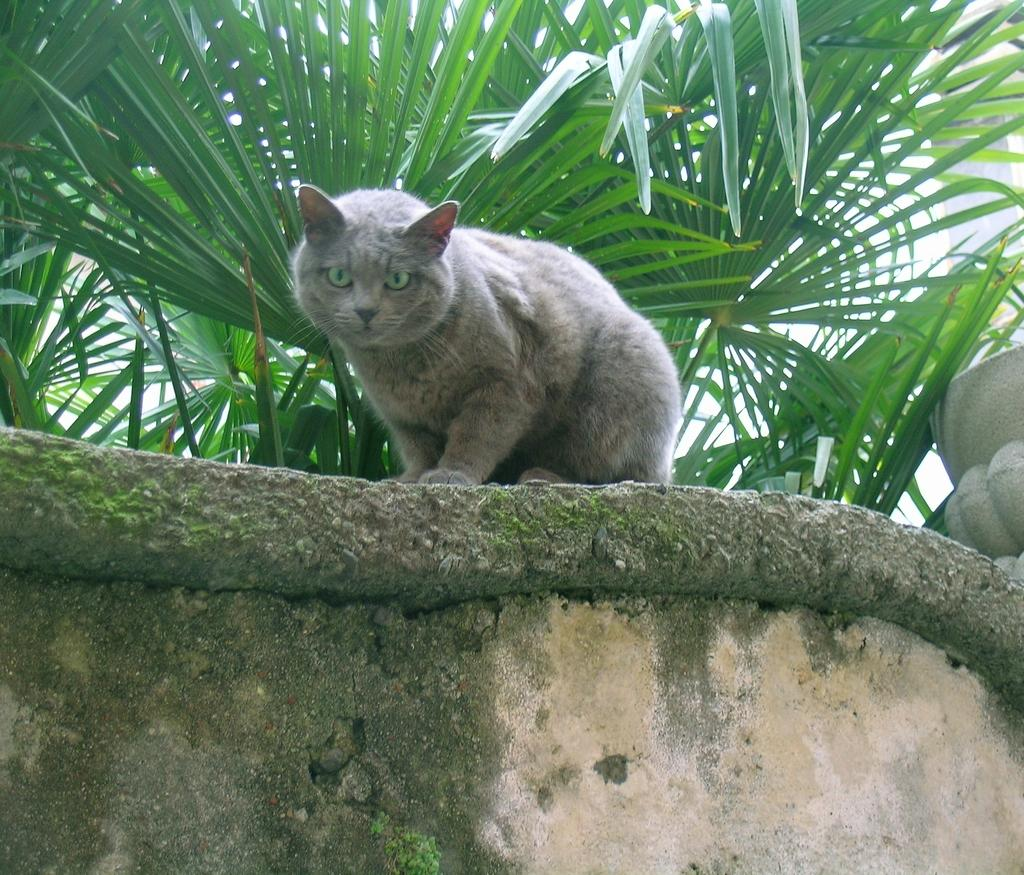What animal can be seen in the image? There is a cat in the image. Where is the cat located in the image? The cat is sitting on a wall. What else can be seen in the image besides the cat? There are plants visible in the image. What type of parenting advice can be seen in the image? There is no parenting advice present in the image; it features a cat sitting on a wall and plants. What kind of teeth can be seen in the image? There are no teeth visible in the image, as it features a cat sitting on a wall and plants. 